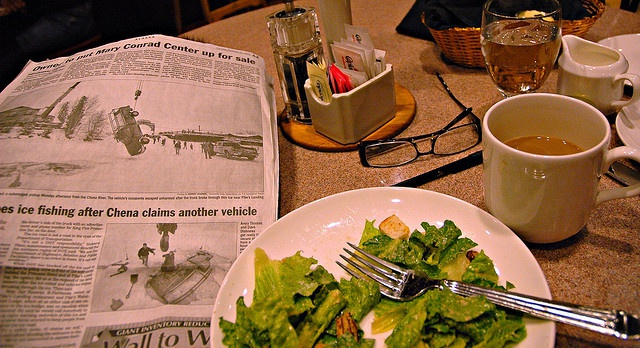Describe the objects in this image and their specific colors. I can see cup in black, olive, maroon, and gray tones, dining table in black, brown, and maroon tones, broccoli in black and olive tones, wine glass in black, maroon, and brown tones, and fork in black, white, olive, and gray tones in this image. 